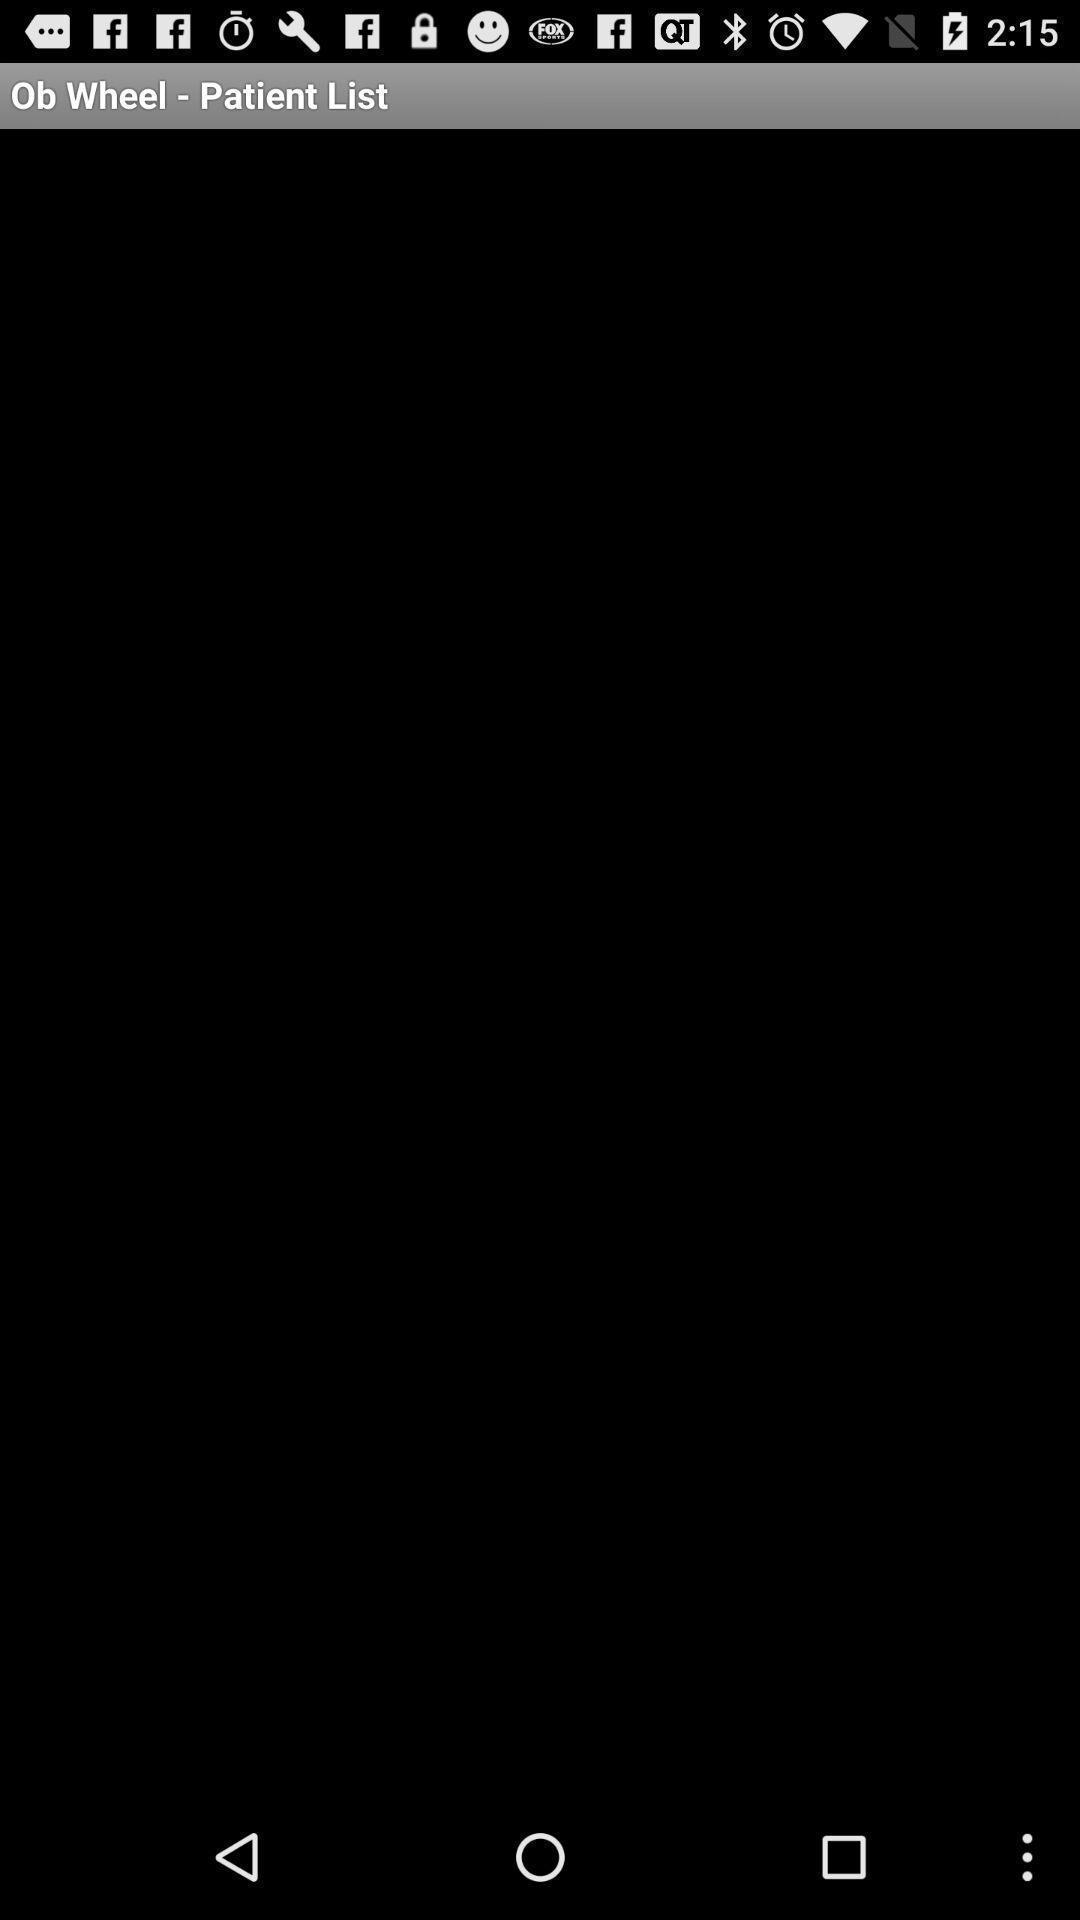Describe the key features of this screenshot. Page showing blank page. 